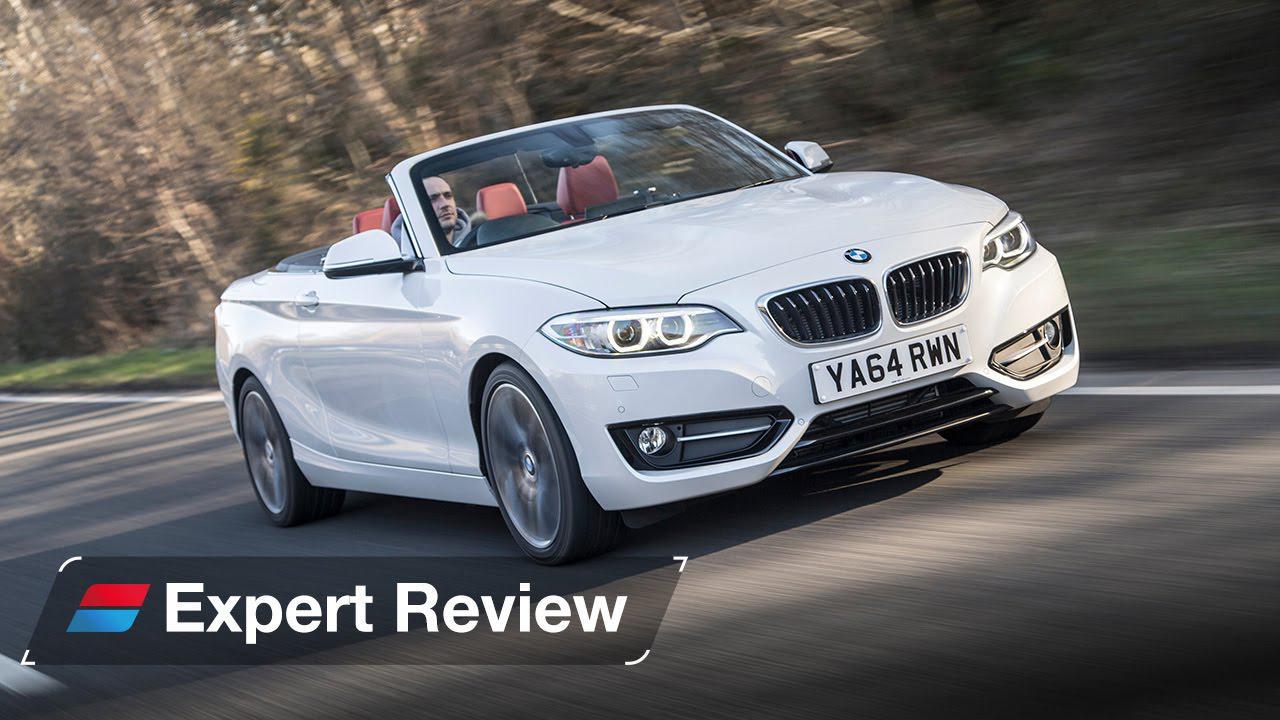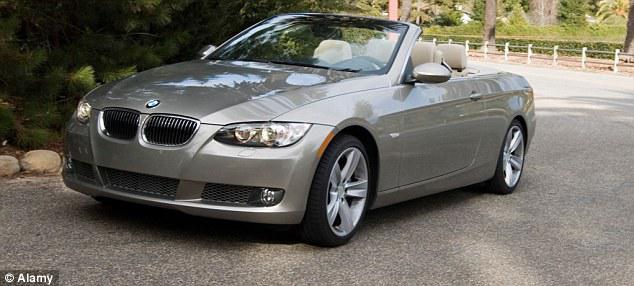The first image is the image on the left, the second image is the image on the right. Considering the images on both sides, is "One car has a hard top and the other car is a topless convertible, and the cars in the left and right images appear to face each other." valid? Answer yes or no. No. The first image is the image on the left, the second image is the image on the right. Evaluate the accuracy of this statement regarding the images: "One of the images features a white convertible car.". Is it true? Answer yes or no. Yes. 